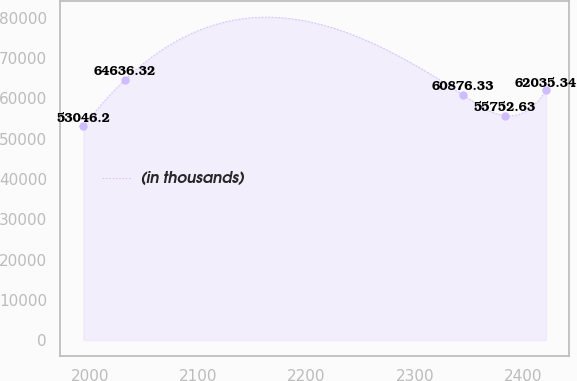Convert chart to OTSL. <chart><loc_0><loc_0><loc_500><loc_500><line_chart><ecel><fcel>(in thousands)<nl><fcel>1994.18<fcel>53046.2<nl><fcel>2032.4<fcel>64636.3<nl><fcel>2344.52<fcel>60876.3<nl><fcel>2382.74<fcel>55752.6<nl><fcel>2420.96<fcel>62035.3<nl></chart> 